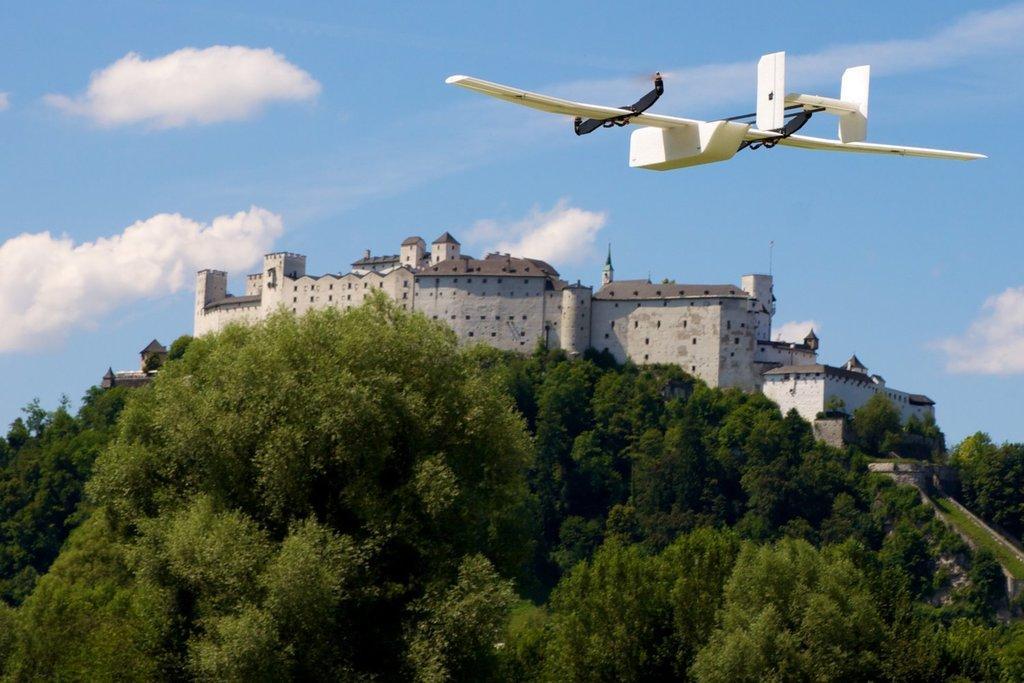In one or two sentences, can you explain what this image depicts? At the bottom of the picture, we see the trees. In the middle of the picture, we see the building or a castle with a grey color roof. At the top, we see an aircraft in white color is flying in the sky. In the background, we see the clouds and the sky, which is blue in color. 